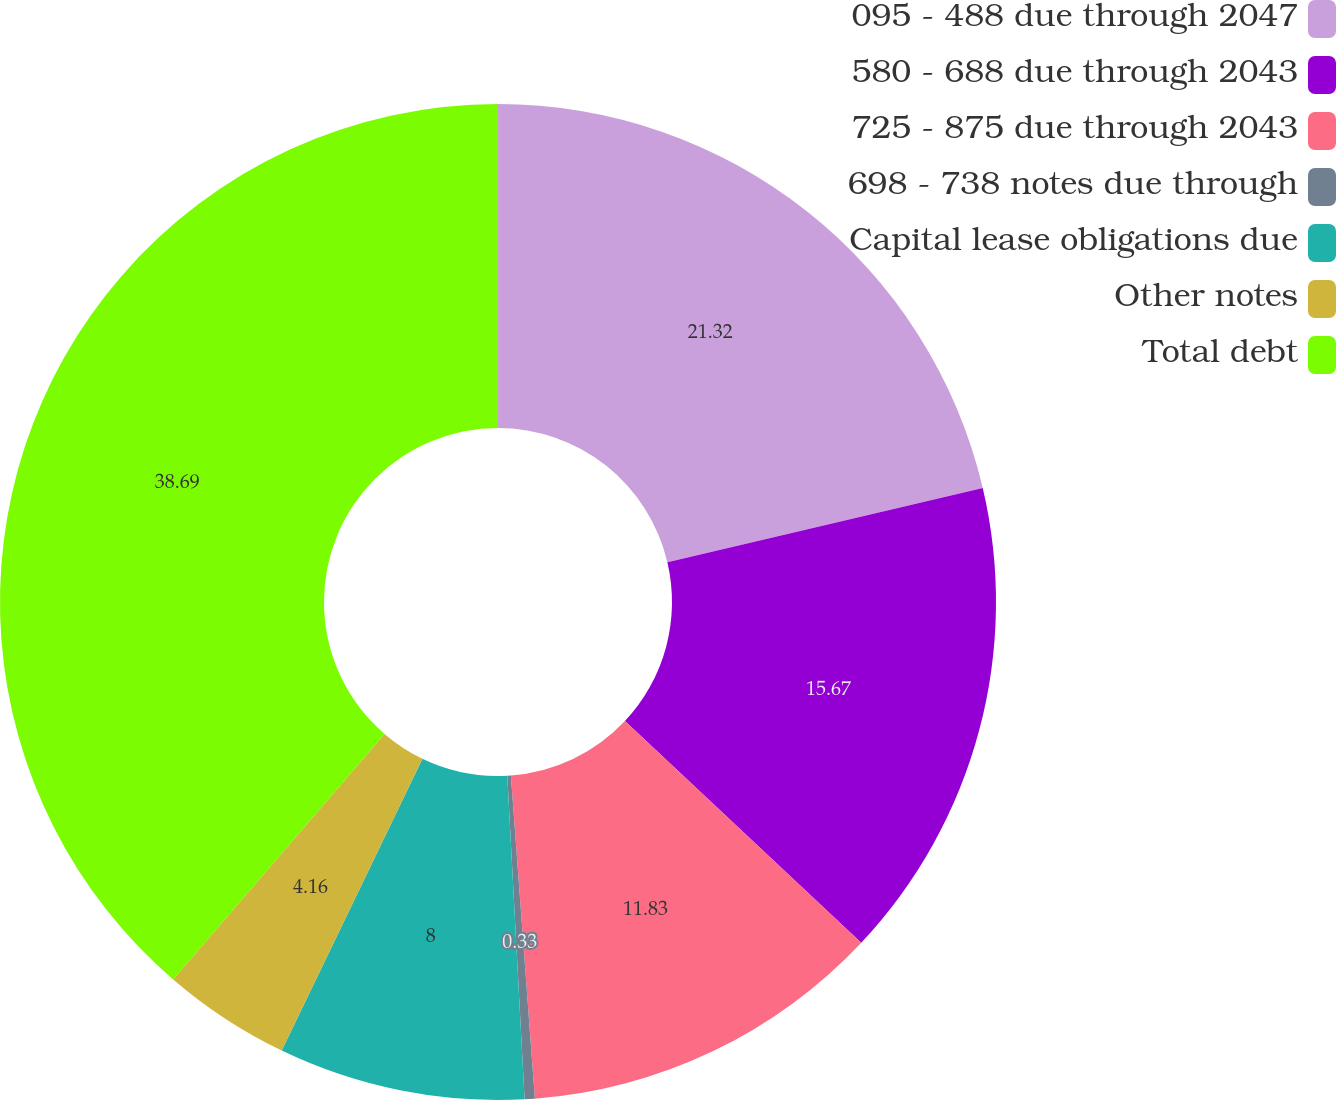Convert chart. <chart><loc_0><loc_0><loc_500><loc_500><pie_chart><fcel>095 - 488 due through 2047<fcel>580 - 688 due through 2043<fcel>725 - 875 due through 2043<fcel>698 - 738 notes due through<fcel>Capital lease obligations due<fcel>Other notes<fcel>Total debt<nl><fcel>21.32%<fcel>15.67%<fcel>11.83%<fcel>0.33%<fcel>8.0%<fcel>4.16%<fcel>38.69%<nl></chart> 